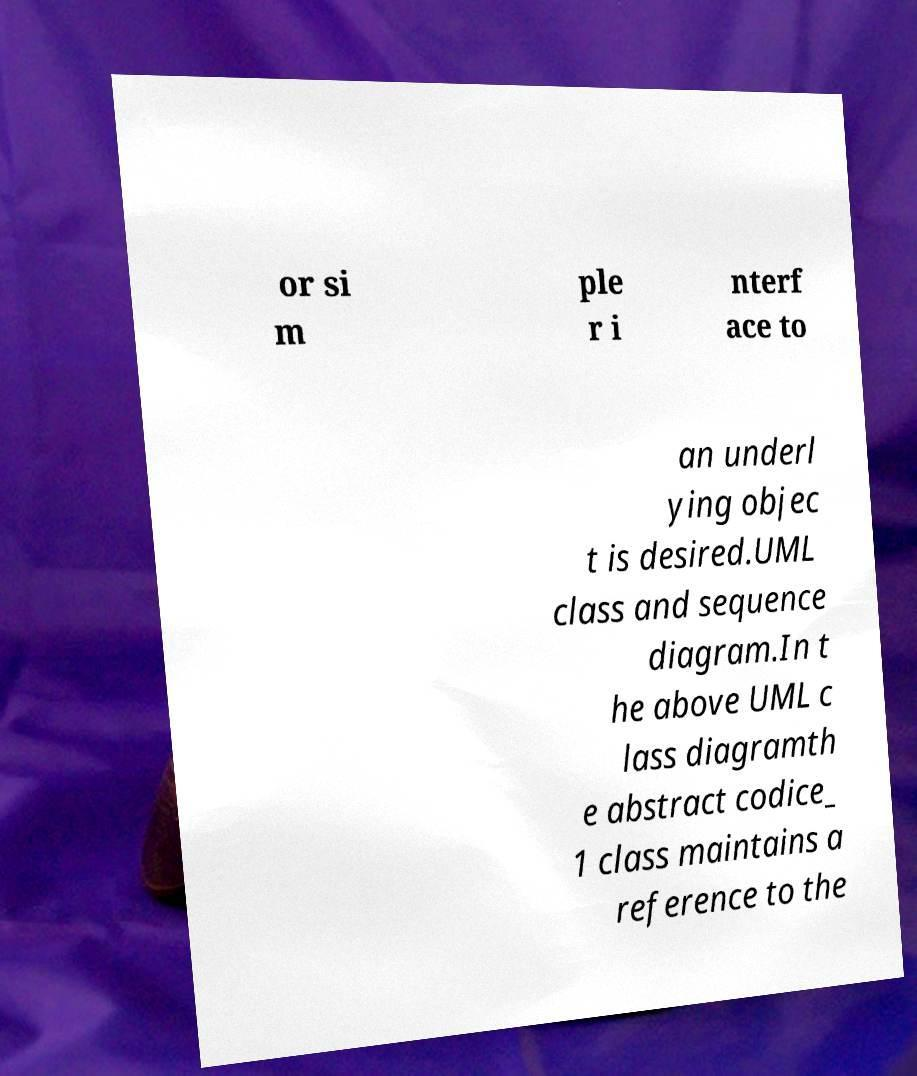There's text embedded in this image that I need extracted. Can you transcribe it verbatim? or si m ple r i nterf ace to an underl ying objec t is desired.UML class and sequence diagram.In t he above UML c lass diagramth e abstract codice_ 1 class maintains a reference to the 